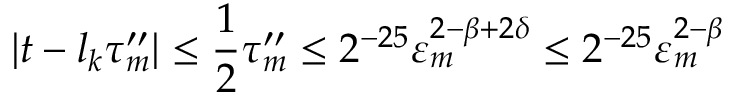<formula> <loc_0><loc_0><loc_500><loc_500>| t - l _ { k } \tau _ { m } ^ { \prime \prime } | \leq \frac { 1 } { 2 } \tau _ { m } ^ { \prime \prime } \leq 2 ^ { - 2 5 } \varepsilon _ { m } ^ { 2 - \beta + 2 \delta } \leq 2 ^ { - 2 5 } \varepsilon _ { m } ^ { 2 - \beta }</formula> 